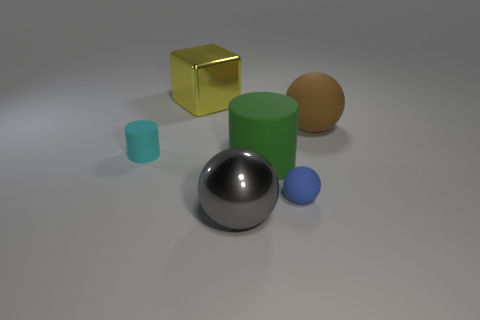Add 3 small blue shiny cubes. How many objects exist? 9 Subtract all big spheres. How many spheres are left? 1 Subtract all gray spheres. How many spheres are left? 2 Subtract 2 spheres. How many spheres are left? 1 Subtract 1 cyan cylinders. How many objects are left? 5 Subtract all blocks. How many objects are left? 5 Subtract all green balls. Subtract all green cubes. How many balls are left? 3 Subtract all gray cubes. How many green balls are left? 0 Subtract all big brown rubber spheres. Subtract all tiny rubber cylinders. How many objects are left? 4 Add 1 small rubber cylinders. How many small rubber cylinders are left? 2 